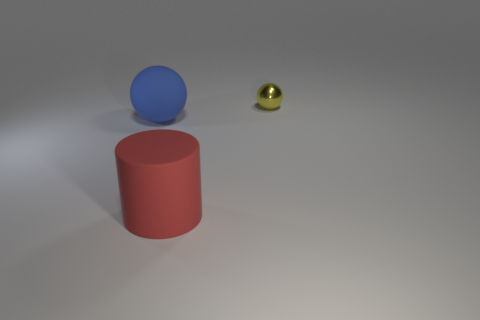What number of other large matte things have the same shape as the yellow object?
Provide a succinct answer. 1. There is a thing that is the same size as the blue sphere; what is its material?
Keep it short and to the point. Rubber. Is there a cyan cylinder that has the same material as the red thing?
Ensure brevity in your answer.  No. Is the number of big blue rubber balls left of the big sphere less than the number of large rubber cylinders?
Give a very brief answer. Yes. What is the material of the large thing on the right side of the sphere on the left side of the yellow thing?
Your answer should be very brief. Rubber. What shape is the object that is on the right side of the large blue matte sphere and on the left side of the yellow shiny ball?
Your answer should be compact. Cylinder. How many other things are there of the same color as the big rubber sphere?
Offer a very short reply. 0. How many objects are spheres in front of the tiny metal thing or red rubber objects?
Your answer should be compact. 2. Is the color of the small shiny object the same as the matte thing on the left side of the large red cylinder?
Ensure brevity in your answer.  No. Is there anything else that has the same size as the red rubber thing?
Provide a succinct answer. Yes. 